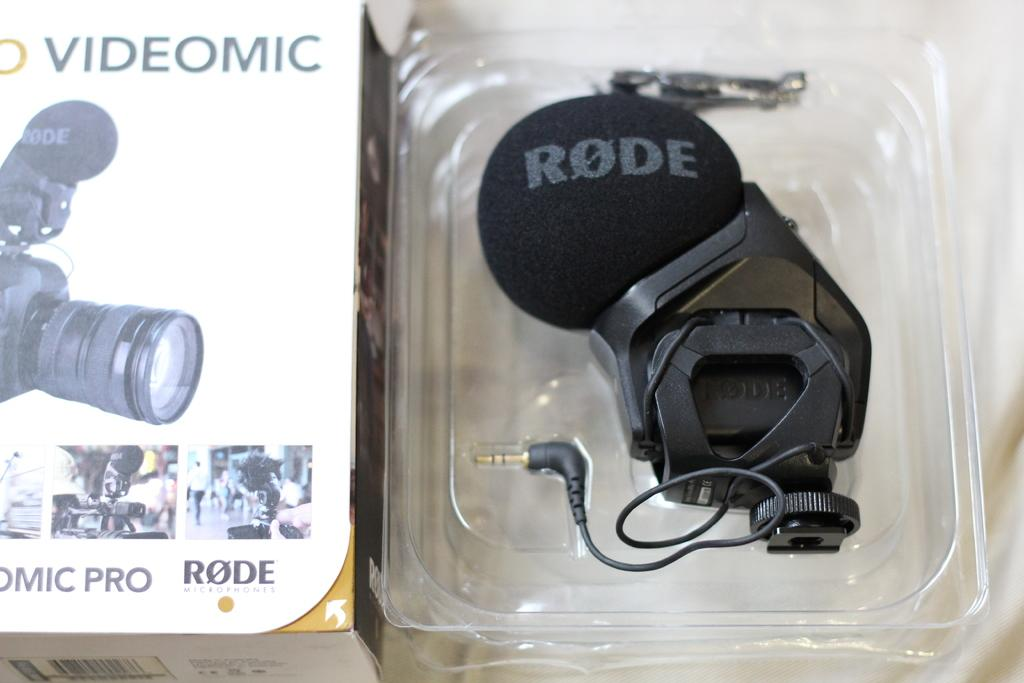What is depicted on the box in the image? The box has images of cameras on it. Can you describe the black object beside the box? There is a black object beside the box, but the image does not provide enough detail to identify it. What type of juice is being poured from the box in the image? There is no juice present in the image, as the box has images of cameras on it. 